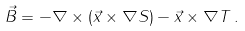<formula> <loc_0><loc_0><loc_500><loc_500>\vec { B } = - \nabla \times ( \vec { x } \times \nabla S ) - \vec { x } \times \nabla T \, .</formula> 